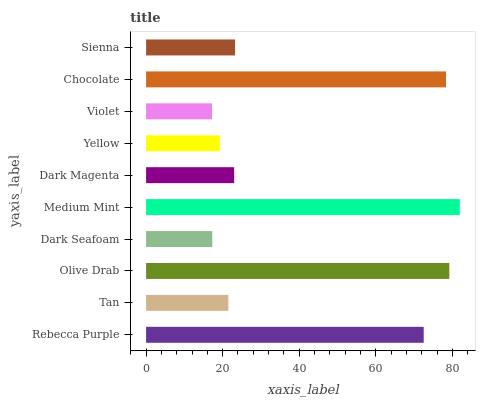Is Violet the minimum?
Answer yes or no. Yes. Is Medium Mint the maximum?
Answer yes or no. Yes. Is Tan the minimum?
Answer yes or no. No. Is Tan the maximum?
Answer yes or no. No. Is Rebecca Purple greater than Tan?
Answer yes or no. Yes. Is Tan less than Rebecca Purple?
Answer yes or no. Yes. Is Tan greater than Rebecca Purple?
Answer yes or no. No. Is Rebecca Purple less than Tan?
Answer yes or no. No. Is Sienna the high median?
Answer yes or no. Yes. Is Dark Magenta the low median?
Answer yes or no. Yes. Is Tan the high median?
Answer yes or no. No. Is Chocolate the low median?
Answer yes or no. No. 